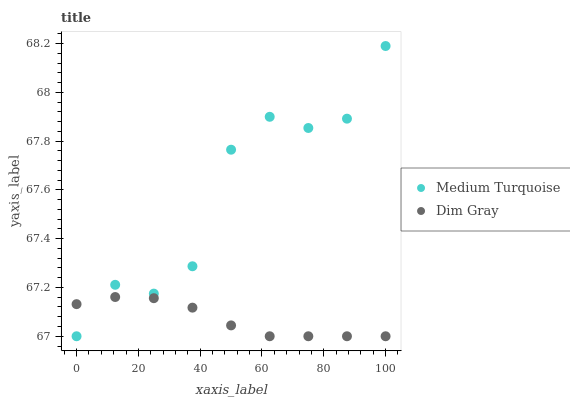Does Dim Gray have the minimum area under the curve?
Answer yes or no. Yes. Does Medium Turquoise have the maximum area under the curve?
Answer yes or no. Yes. Does Medium Turquoise have the minimum area under the curve?
Answer yes or no. No. Is Dim Gray the smoothest?
Answer yes or no. Yes. Is Medium Turquoise the roughest?
Answer yes or no. Yes. Is Medium Turquoise the smoothest?
Answer yes or no. No. Does Dim Gray have the lowest value?
Answer yes or no. Yes. Does Medium Turquoise have the highest value?
Answer yes or no. Yes. Does Dim Gray intersect Medium Turquoise?
Answer yes or no. Yes. Is Dim Gray less than Medium Turquoise?
Answer yes or no. No. Is Dim Gray greater than Medium Turquoise?
Answer yes or no. No. 